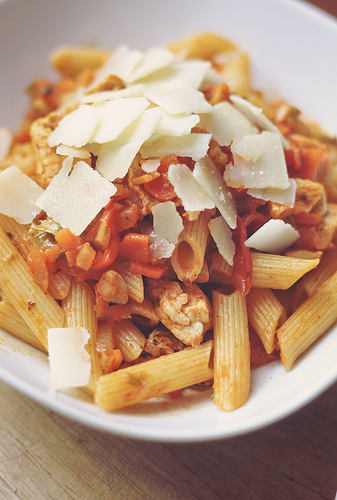<image>
Can you confirm if the cheese is above the pasta? Yes. The cheese is positioned above the pasta in the vertical space, higher up in the scene. 